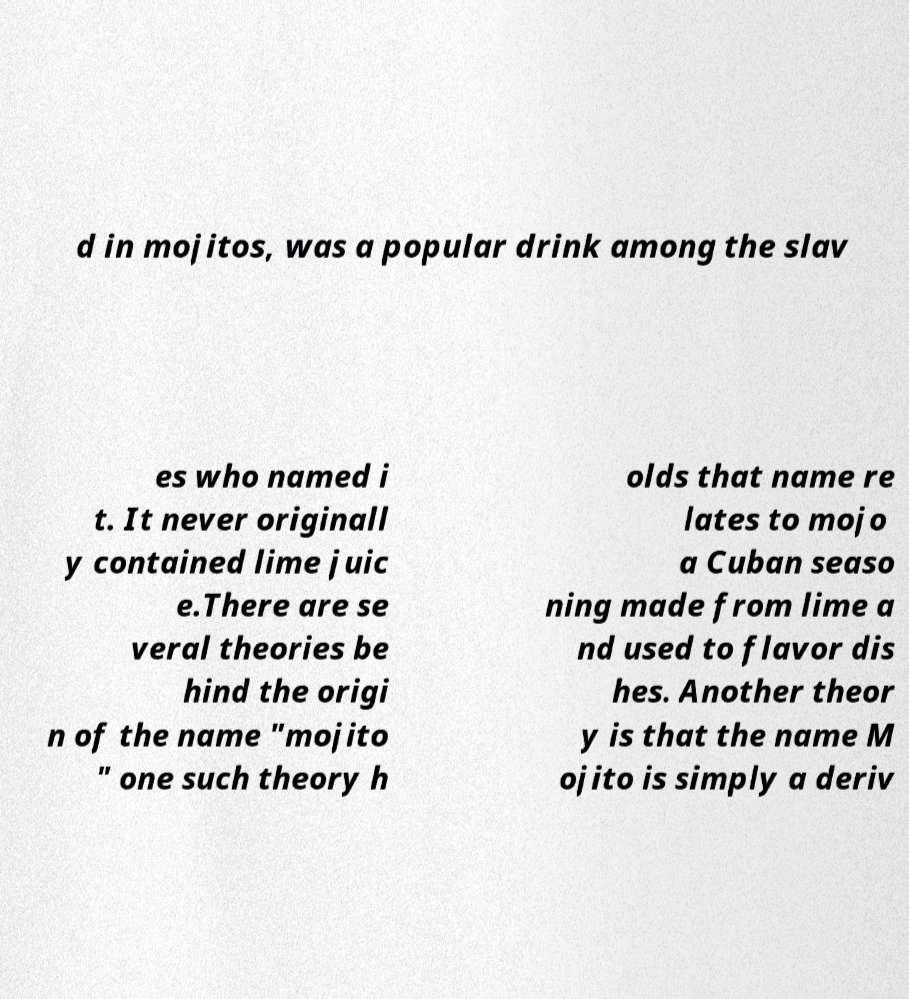What messages or text are displayed in this image? I need them in a readable, typed format. d in mojitos, was a popular drink among the slav es who named i t. It never originall y contained lime juic e.There are se veral theories be hind the origi n of the name "mojito " one such theory h olds that name re lates to mojo a Cuban seaso ning made from lime a nd used to flavor dis hes. Another theor y is that the name M ojito is simply a deriv 